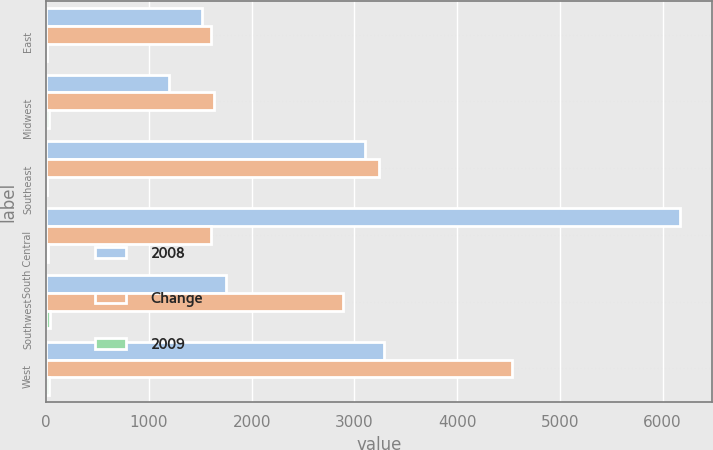<chart> <loc_0><loc_0><loc_500><loc_500><stacked_bar_chart><ecel><fcel>East<fcel>Midwest<fcel>Southeast<fcel>South Central<fcel>Southwest<fcel>West<nl><fcel>2008<fcel>1519<fcel>1198<fcel>3107<fcel>6172<fcel>1751<fcel>3287<nl><fcel>Change<fcel>1602<fcel>1633<fcel>3235<fcel>1602<fcel>2891<fcel>4533<nl><fcel>2009<fcel>5<fcel>27<fcel>4<fcel>16<fcel>39<fcel>27<nl></chart> 